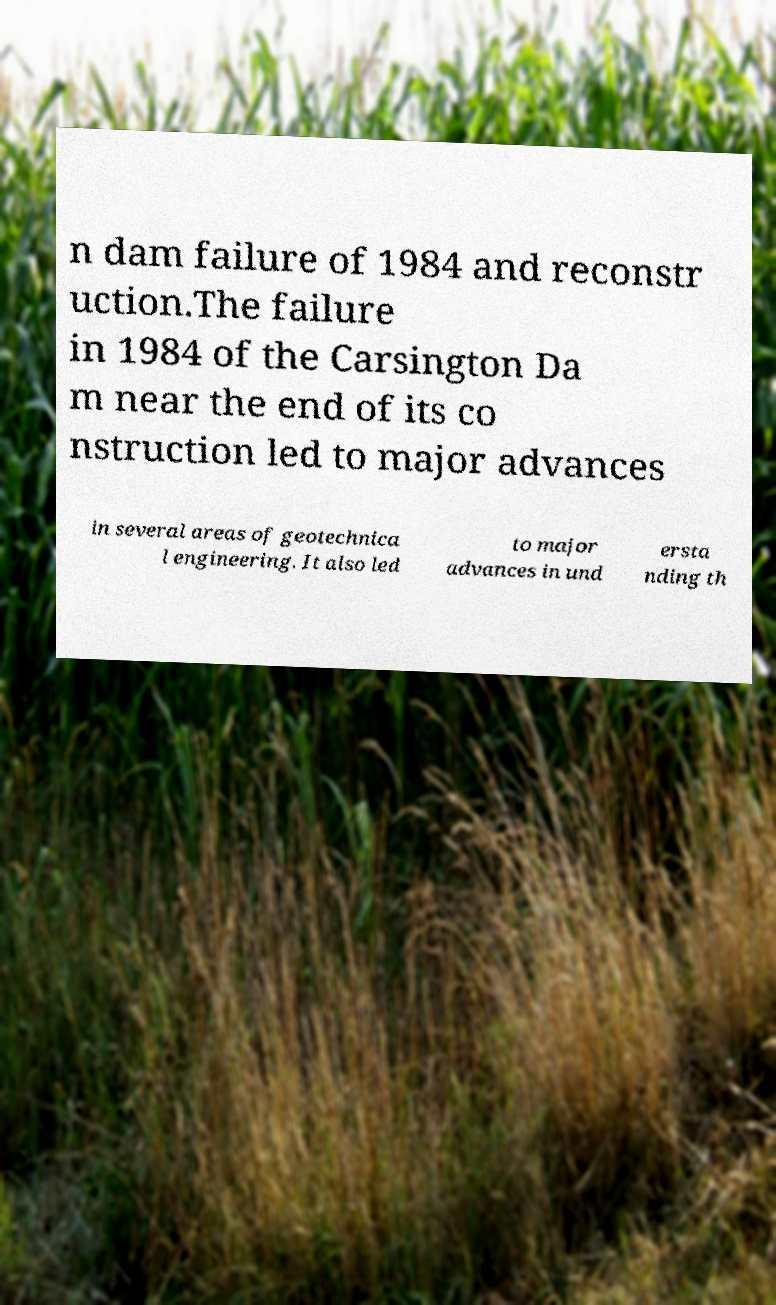Can you accurately transcribe the text from the provided image for me? n dam failure of 1984 and reconstr uction.The failure in 1984 of the Carsington Da m near the end of its co nstruction led to major advances in several areas of geotechnica l engineering. It also led to major advances in und ersta nding th 